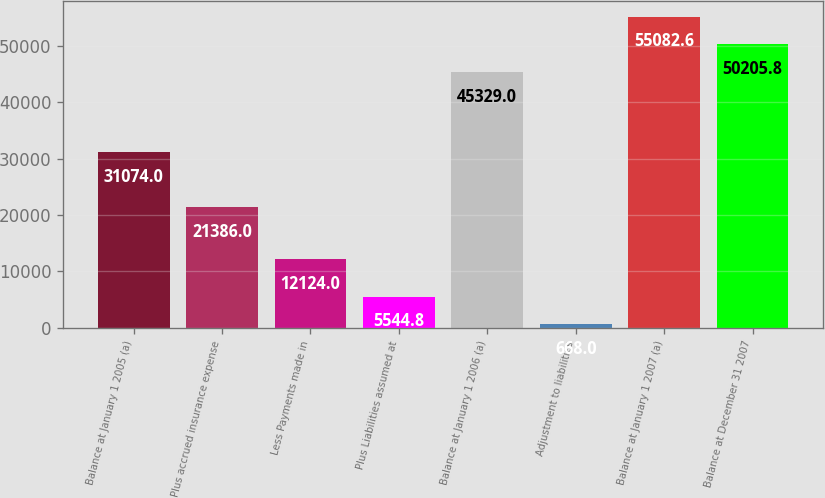Convert chart to OTSL. <chart><loc_0><loc_0><loc_500><loc_500><bar_chart><fcel>Balance at January 1 2005 (a)<fcel>Plus accrued insurance expense<fcel>Less Payments made in<fcel>Plus Liabilities assumed at<fcel>Balance at January 1 2006 (a)<fcel>Adjustment to liabilities<fcel>Balance at January 1 2007 (a)<fcel>Balance at December 31 2007<nl><fcel>31074<fcel>21386<fcel>12124<fcel>5544.8<fcel>45329<fcel>668<fcel>55082.6<fcel>50205.8<nl></chart> 